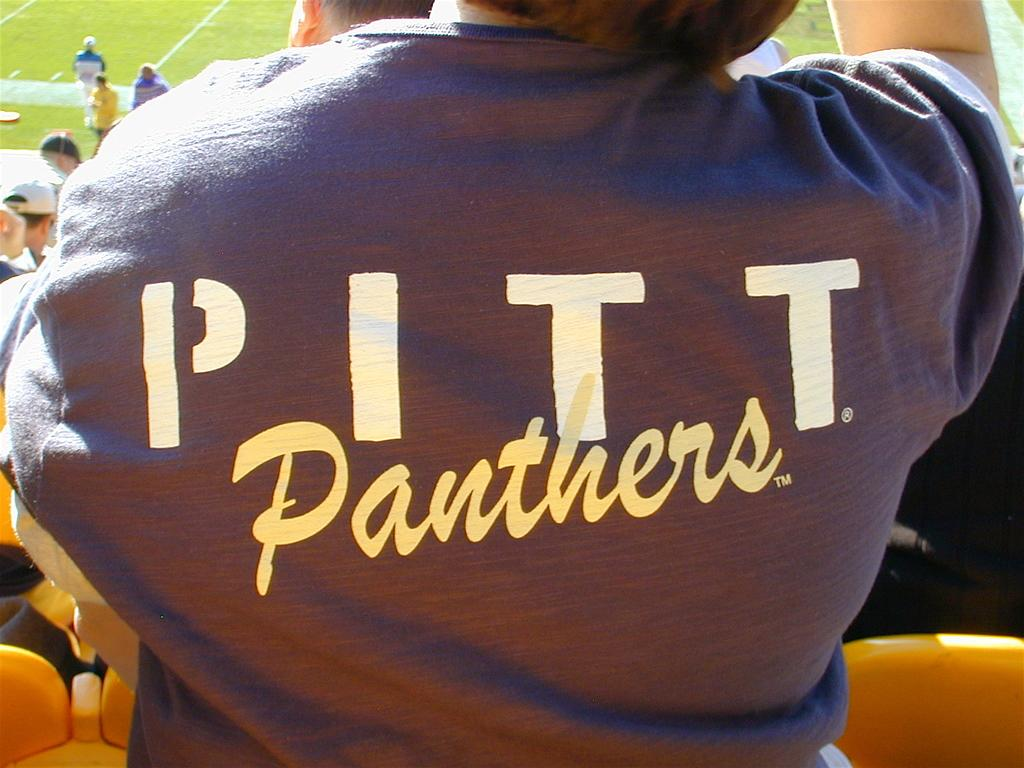<image>
Offer a succinct explanation of the picture presented. A person in a crowd is shown from behind wearing a shirt that says "PITT Panthers." 